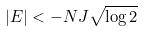Convert formula to latex. <formula><loc_0><loc_0><loc_500><loc_500>| E | < - N J \sqrt { \log 2 }</formula> 